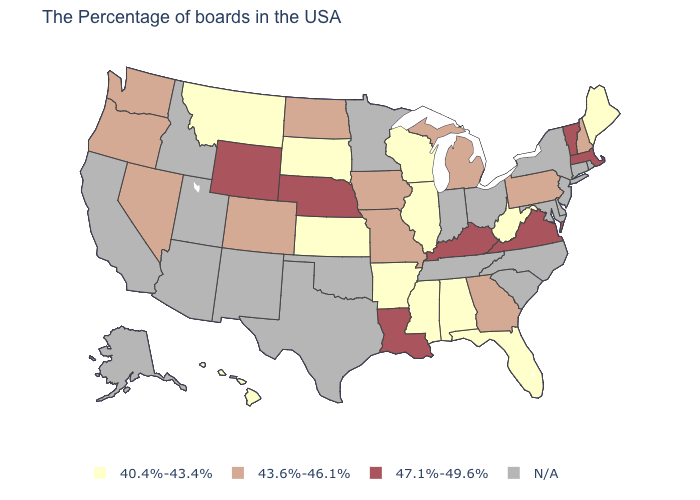What is the value of Washington?
Quick response, please. 43.6%-46.1%. What is the highest value in the USA?
Quick response, please. 47.1%-49.6%. Which states hav the highest value in the MidWest?
Answer briefly. Nebraska. What is the value of Oklahoma?
Be succinct. N/A. Does Pennsylvania have the lowest value in the USA?
Short answer required. No. Does Illinois have the lowest value in the USA?
Short answer required. Yes. Does the map have missing data?
Quick response, please. Yes. Does Florida have the highest value in the South?
Write a very short answer. No. Does Kentucky have the highest value in the USA?
Give a very brief answer. Yes. Name the states that have a value in the range 43.6%-46.1%?
Quick response, please. New Hampshire, Pennsylvania, Georgia, Michigan, Missouri, Iowa, North Dakota, Colorado, Nevada, Washington, Oregon. Does Massachusetts have the lowest value in the Northeast?
Concise answer only. No. 